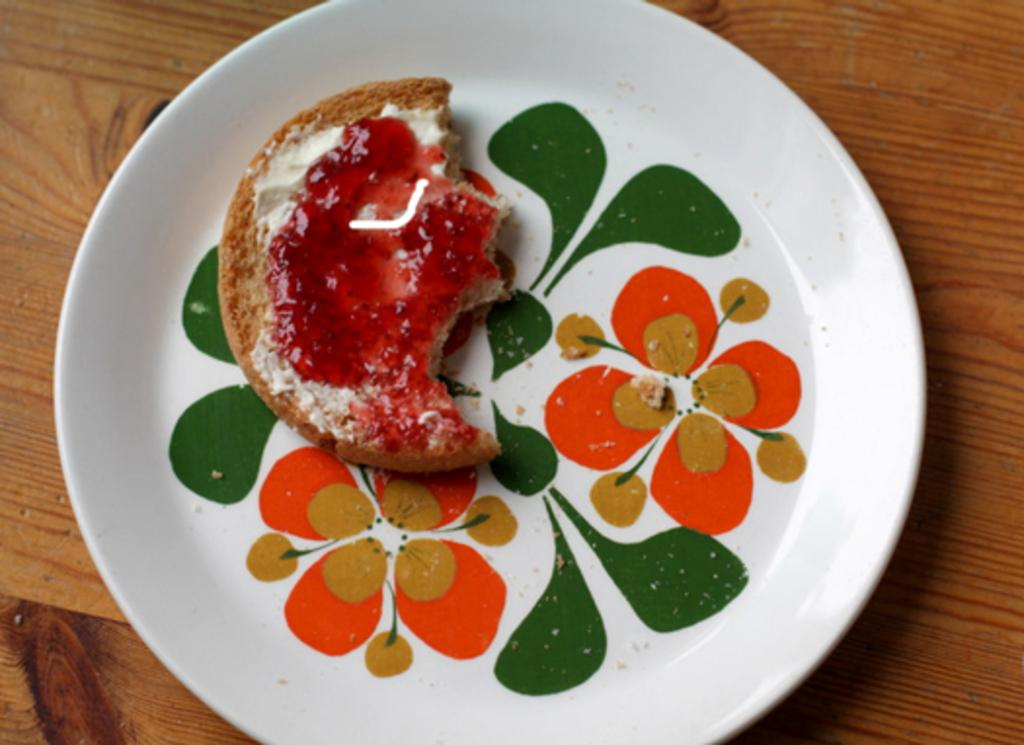What is the main subject of the image? There is a food item in the image. How is the food item presented? The food item is in a plate. What type of furniture is visible in the image? There is a wooden table in the image. What type of scent can be detected from the pie in the image? There is no pie present in the image, so it is not possible to determine what scent might be detected. 